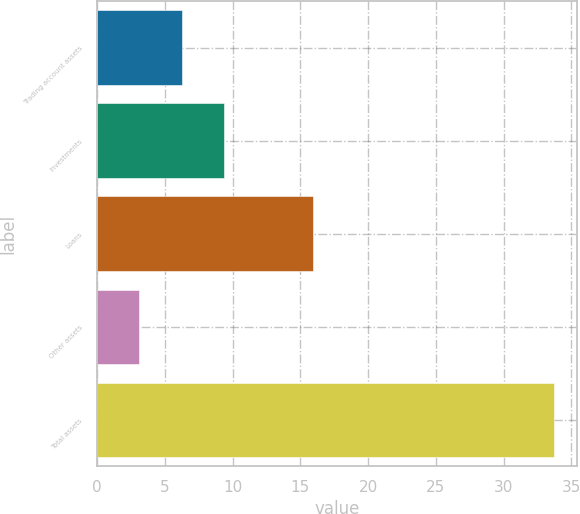Convert chart to OTSL. <chart><loc_0><loc_0><loc_500><loc_500><bar_chart><fcel>Trading account assets<fcel>Investments<fcel>Loans<fcel>Other assets<fcel>Total assets<nl><fcel>6.3<fcel>9.36<fcel>15.9<fcel>3.1<fcel>33.7<nl></chart> 